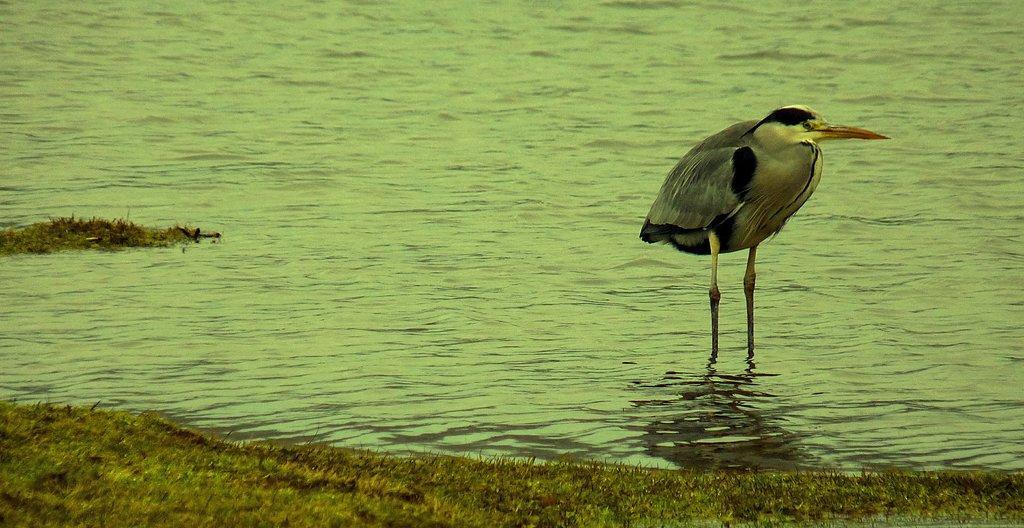Could you give a brief overview of what you see in this image? In this picture I can see there is a bird standing on the right side and it is standing in the water. There is some grass on the floor. 